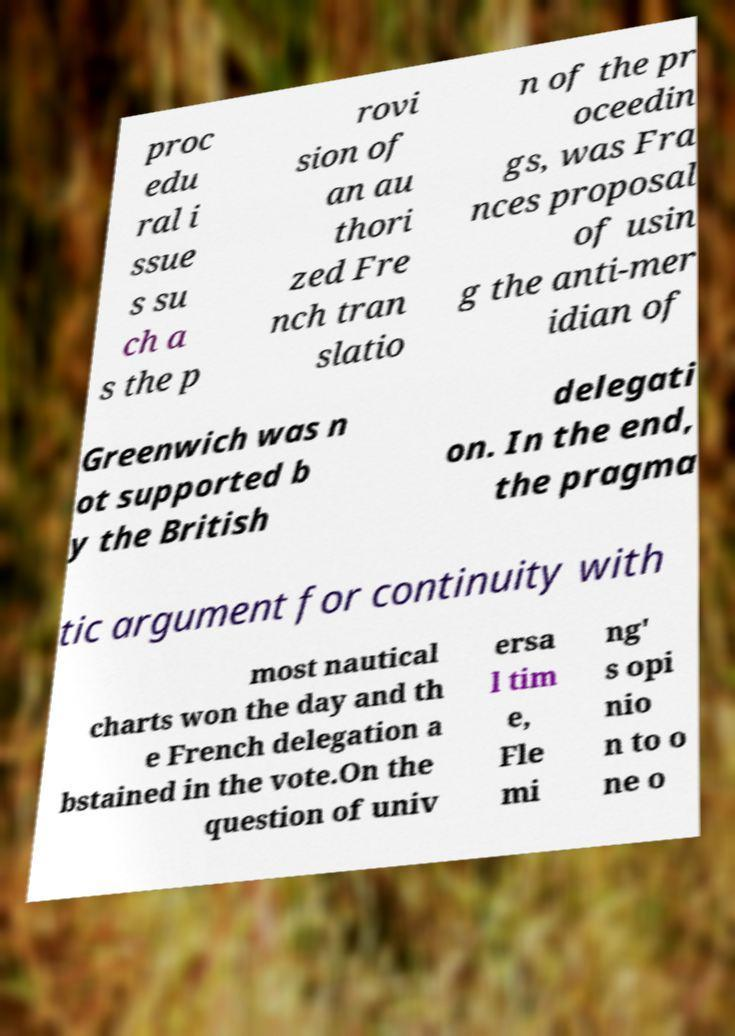Can you accurately transcribe the text from the provided image for me? proc edu ral i ssue s su ch a s the p rovi sion of an au thori zed Fre nch tran slatio n of the pr oceedin gs, was Fra nces proposal of usin g the anti-mer idian of Greenwich was n ot supported b y the British delegati on. In the end, the pragma tic argument for continuity with most nautical charts won the day and th e French delegation a bstained in the vote.On the question of univ ersa l tim e, Fle mi ng' s opi nio n to o ne o 